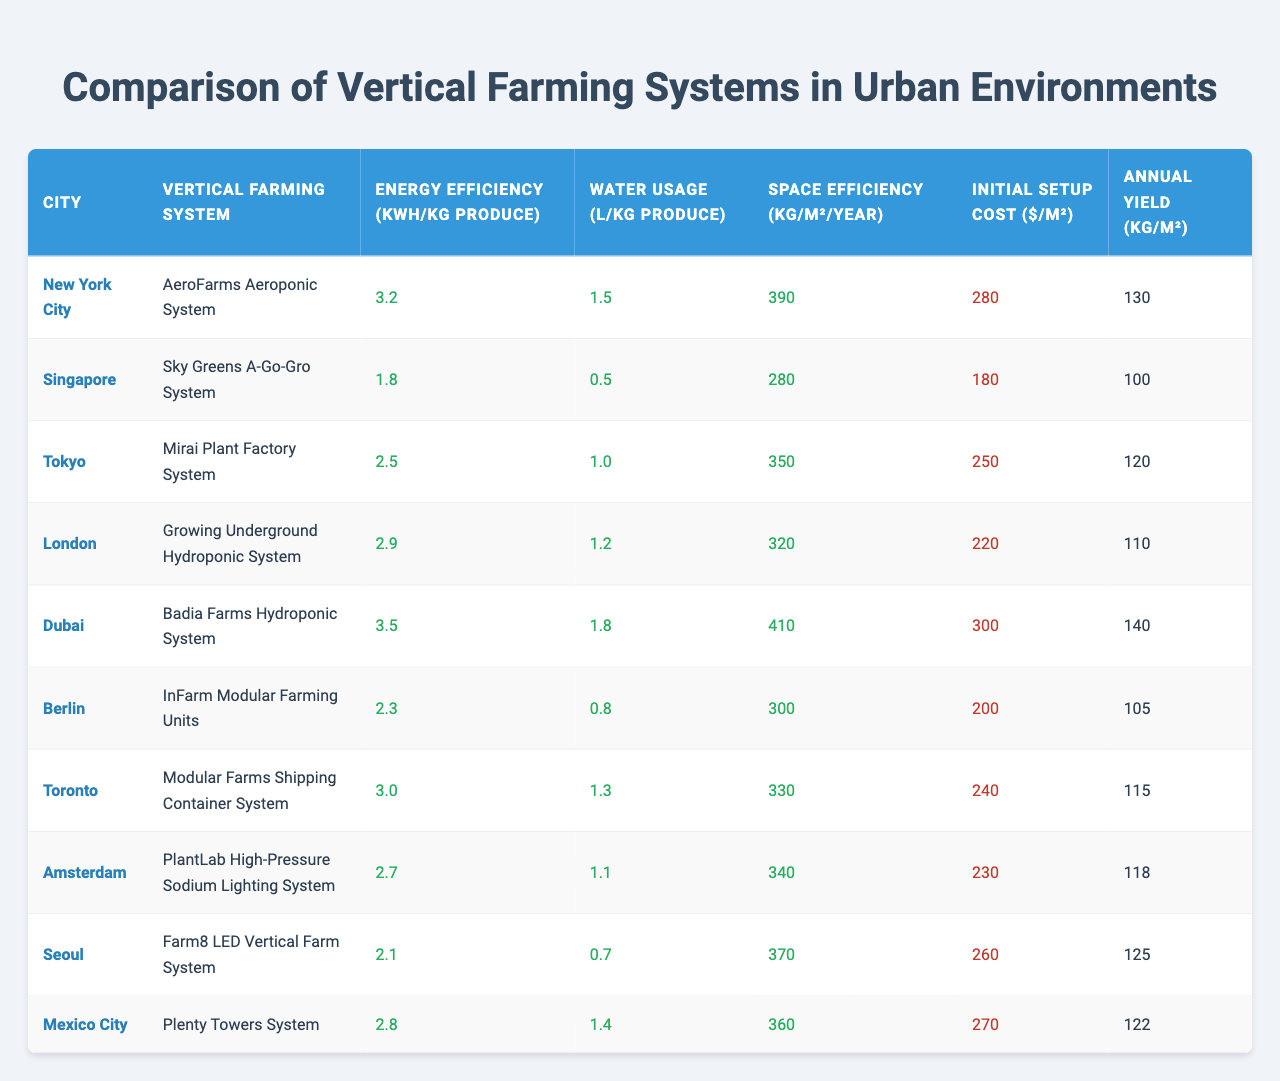What is the energy efficiency of the vertical farming system in Amsterdam? Referring to the table, the energy efficiency for the PlantLab High-Pressure Sodium Lighting System in Amsterdam is listed as 2.7 kWh/kg produce.
Answer: 2.7 kWh/kg produce Which city has the lowest water usage per kilogram of produce? By examining the water usage column in the table, Singapore has the lowest water usage at 0.5 L/kg produce.
Answer: Singapore What is the average initial setup cost of the vertical farming systems listed? To find the average setup cost, add the costs: 280 + 180 + 250 + 220 + 300 + 200 + 240 + 230 + 260 + 270 = 2370, then divide by the number of systems (10), which gives 2370/10 = 237.
Answer: 237 Is the energy efficiency of the Badia Farms Hydroponic System higher than that of the Growing Underground Hydroponic System? Comparing the values in the table, Badia Farms has an efficiency of 3.5 kWh/kg and Growing Underground has 2.9 kWh/kg. Since 3.5 is greater than 2.9, the statement is true.
Answer: Yes What is the city with the highest space efficiency? By looking at the space efficiency values, Dubai has the highest at 410 kg/m²/year, as shown in the table.
Answer: Dubai How much more energy efficient is the AeroFarms Aeroponic System compared to the Farm8 LED Vertical Farm System? The AeroFarms Aeroponic System has an energy efficiency of 3.2 kWh/kg, while Farm8 has 2.1 kWh/kg. The difference is 3.2 - 2.1 = 1.1 kWh/kg.
Answer: 1.1 kWh/kg Which vertical farming system has the highest annual yield? The table indicates that the Badia Farms Hydroponic System has the highest annual yield of 140 kg/m².
Answer: Badia Farms Hydroponic System If we were to sort all cities by annual yield in descending order, which city would come last? The annual yields as per the table are listed, and the yields in order are: 140, 130, 125, 122, 120, 118, 115, 110, 105, and 100. The last value is Singapore with an annual yield of 100 kg/m².
Answer: Singapore What is the water usage for the Mirai Plant Factory System? The table shows that the water usage for the Mirai Plant Factory System in Tokyo is 1.0 L/kg produce.
Answer: 1.0 L/kg produce How do the initial setup costs compare between the systems in New York City and Toronto? The initial setup cost for the AeroFarms system in New York City is 280 $/m², while the Modular Farms Shipping Container System in Toronto costs 240 $/m². This shows that New York City's setup cost is higher by 40 $.
Answer: New York City is higher by 40 $ 